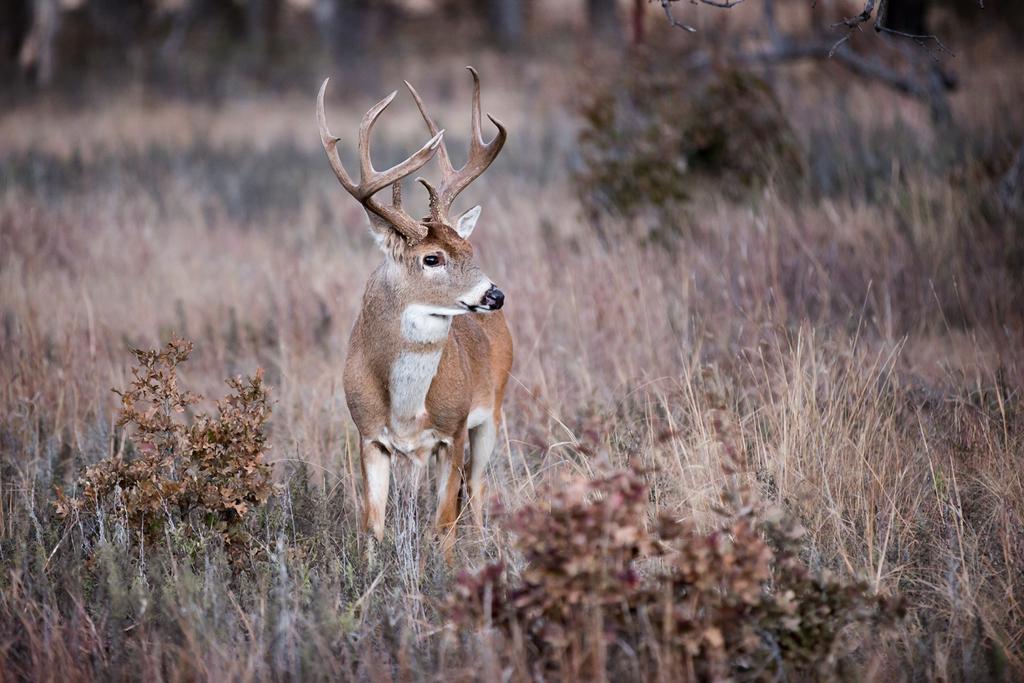Please provide a concise description of this image. In this image there is a deer standing in the dry grass. At the bottom there are small plants and dry grass. 